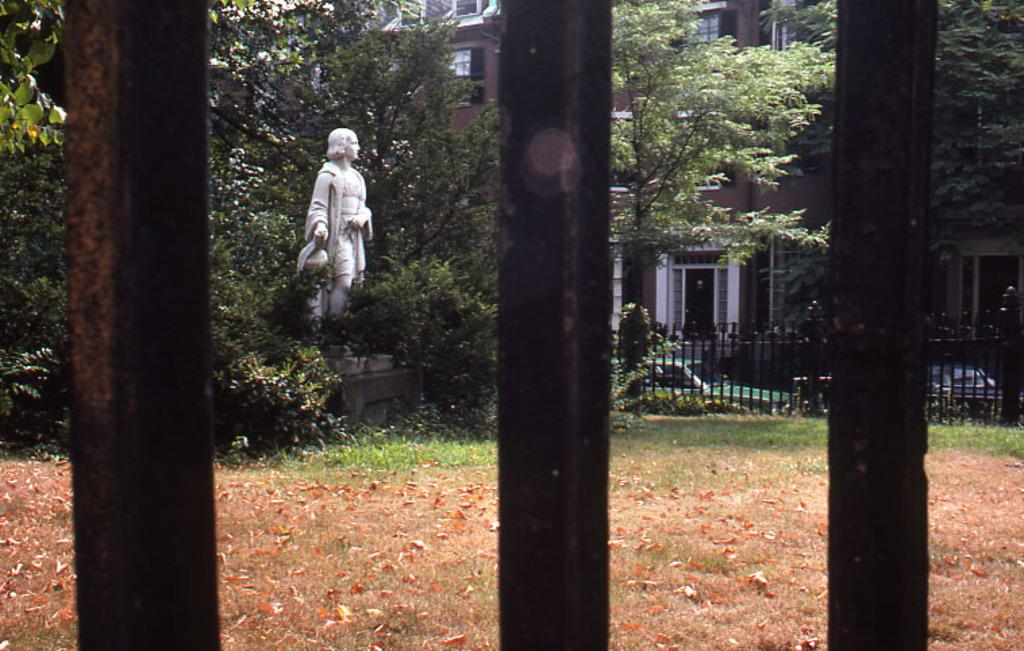What objects can be seen in the foreground of the image? There are three rods in the foreground of the image. What is located in the background of the image? There is a sculpture in the background of the image. What type of vegetation is present in the background of the image? There are trees and plants in the background of the image. What is the ground made of in the background of the image? Grass is present in the background of the image. What architectural feature can be seen in the background of the image? There is a railing in the background of the image. What type of man-made structures are visible in the background of the image? There are buildings in the background of the image. What else can be seen in the background of the image? Vehicles and trees are visible in the background of the image. How many pigs are comfortably resting under the tree in the image? There are no pigs present in the image, and therefore no such activity can be observed. 